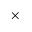Convert formula to latex. <formula><loc_0><loc_0><loc_500><loc_500>\times</formula> 